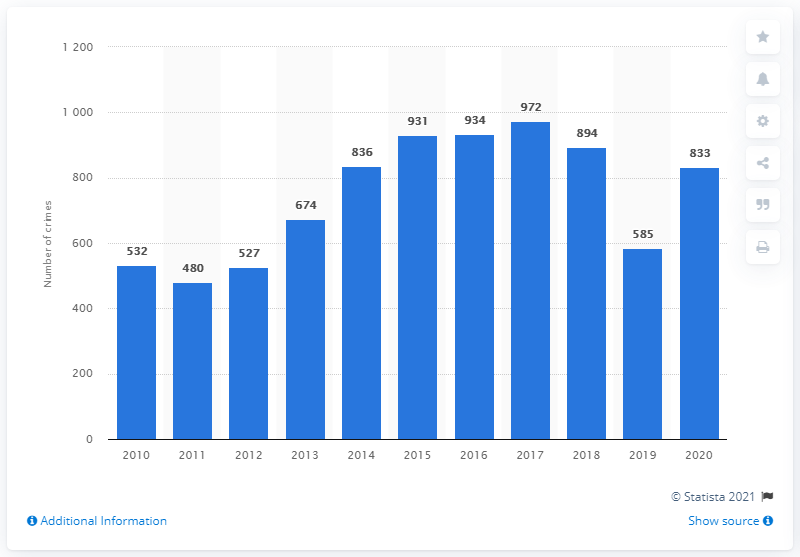Draw attention to some important aspects in this diagram. There were 585 crimes related to extremism in Russia in the previous year. In 2020, there were 833 reported crimes related to extremism in Russia. 